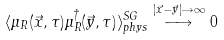Convert formula to latex. <formula><loc_0><loc_0><loc_500><loc_500>\langle \mu _ { R } ( \vec { x } , \tau ) \mu _ { R } ^ { \dagger } ( \vec { y } , \tau ) \rangle _ { p h y s } ^ { S G } \stackrel { | \vec { x } - \vec { y } | \rightarrow \infty } \longrightarrow 0</formula> 